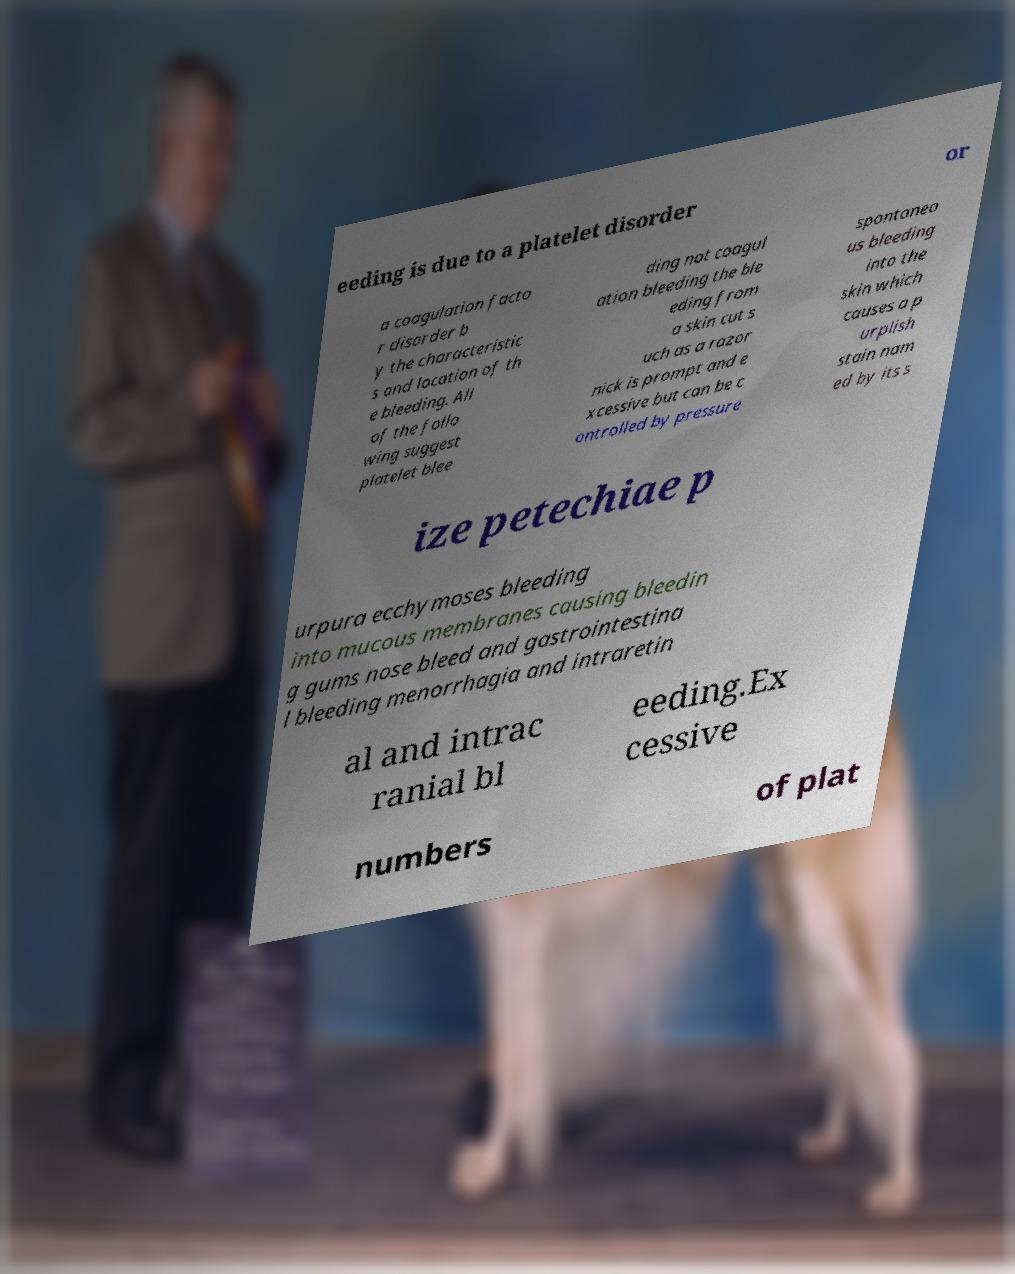Could you assist in decoding the text presented in this image and type it out clearly? eeding is due to a platelet disorder or a coagulation facto r disorder b y the characteristic s and location of th e bleeding. All of the follo wing suggest platelet blee ding not coagul ation bleeding the ble eding from a skin cut s uch as a razor nick is prompt and e xcessive but can be c ontrolled by pressure spontaneo us bleeding into the skin which causes a p urplish stain nam ed by its s ize petechiae p urpura ecchymoses bleeding into mucous membranes causing bleedin g gums nose bleed and gastrointestina l bleeding menorrhagia and intraretin al and intrac ranial bl eeding.Ex cessive numbers of plat 